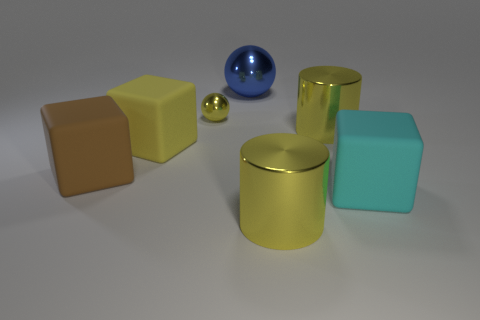Add 2 metal cylinders. How many objects exist? 9 Subtract 1 cubes. How many cubes are left? 2 Subtract all blue balls. How many balls are left? 1 Subtract all cubes. How many objects are left? 4 Subtract all gray cubes. Subtract all cyan cylinders. How many cubes are left? 3 Subtract all large cyan rubber objects. Subtract all yellow balls. How many objects are left? 5 Add 1 large blue metallic objects. How many large blue metallic objects are left? 2 Add 7 yellow spheres. How many yellow spheres exist? 8 Subtract 1 yellow balls. How many objects are left? 6 